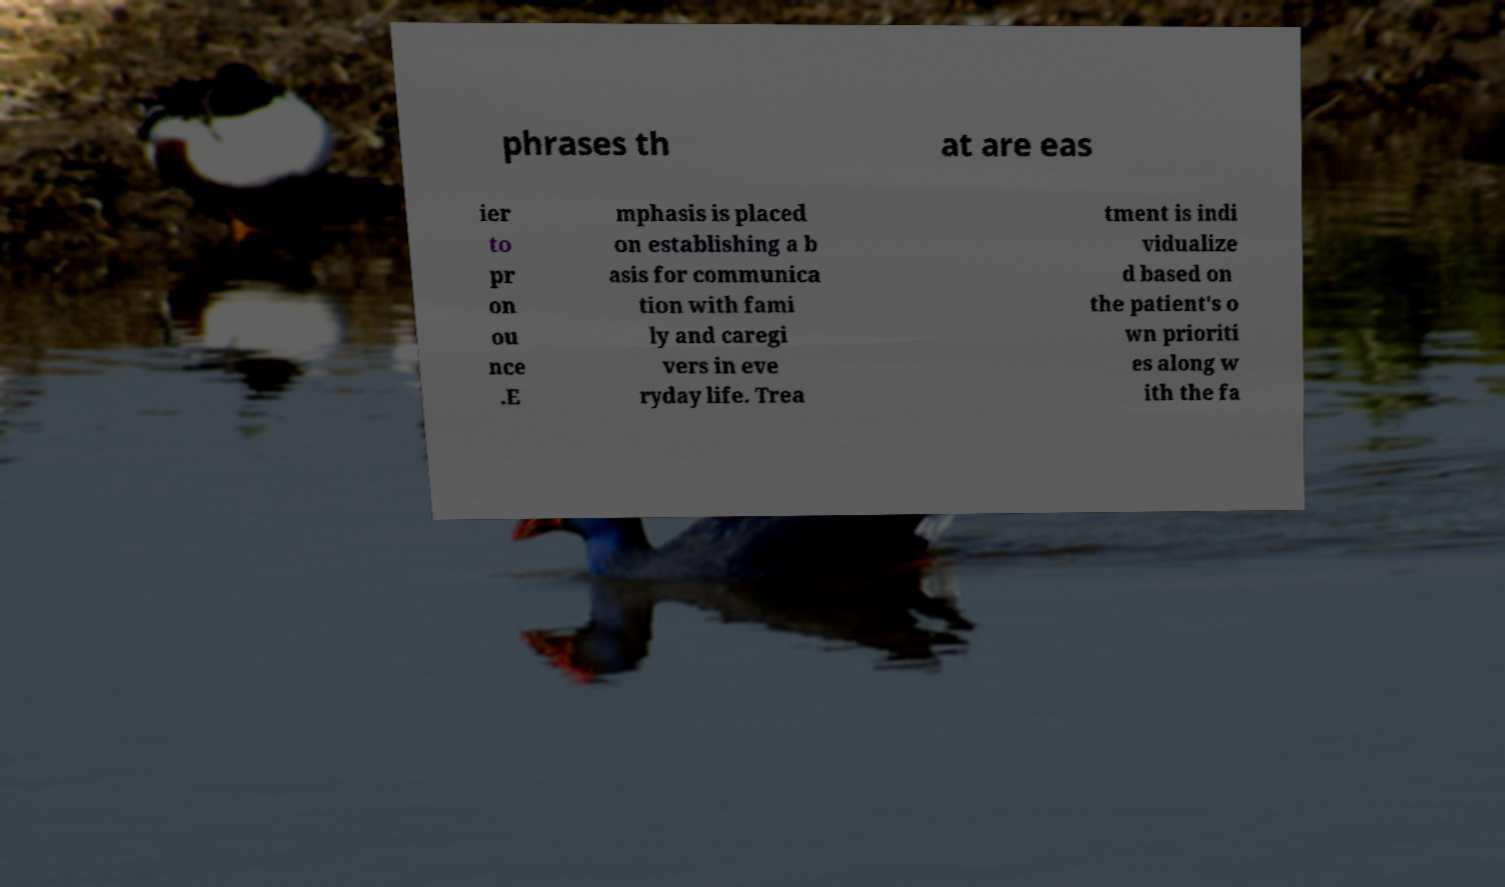There's text embedded in this image that I need extracted. Can you transcribe it verbatim? phrases th at are eas ier to pr on ou nce .E mphasis is placed on establishing a b asis for communica tion with fami ly and caregi vers in eve ryday life. Trea tment is indi vidualize d based on the patient's o wn prioriti es along w ith the fa 